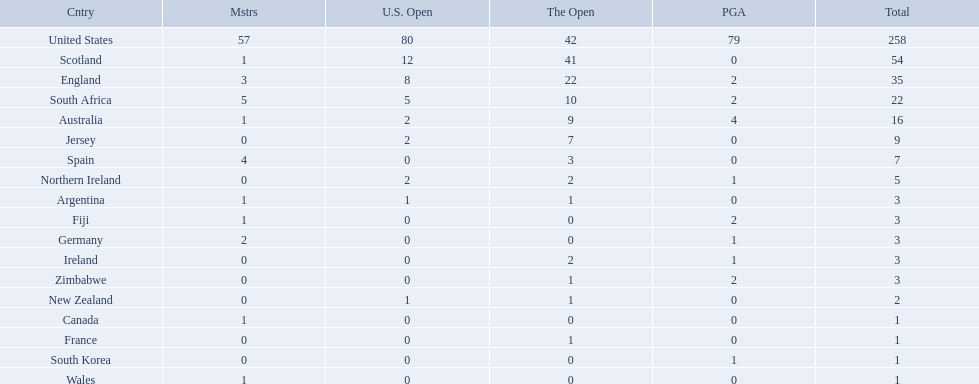What are all the countries? United States, Scotland, England, South Africa, Australia, Jersey, Spain, Northern Ireland, Argentina, Fiji, Germany, Ireland, Zimbabwe, New Zealand, Canada, France, South Korea, Wales. Which ones are located in africa? South Africa, Zimbabwe. Of those, which has the least champion golfers? Zimbabwe. 